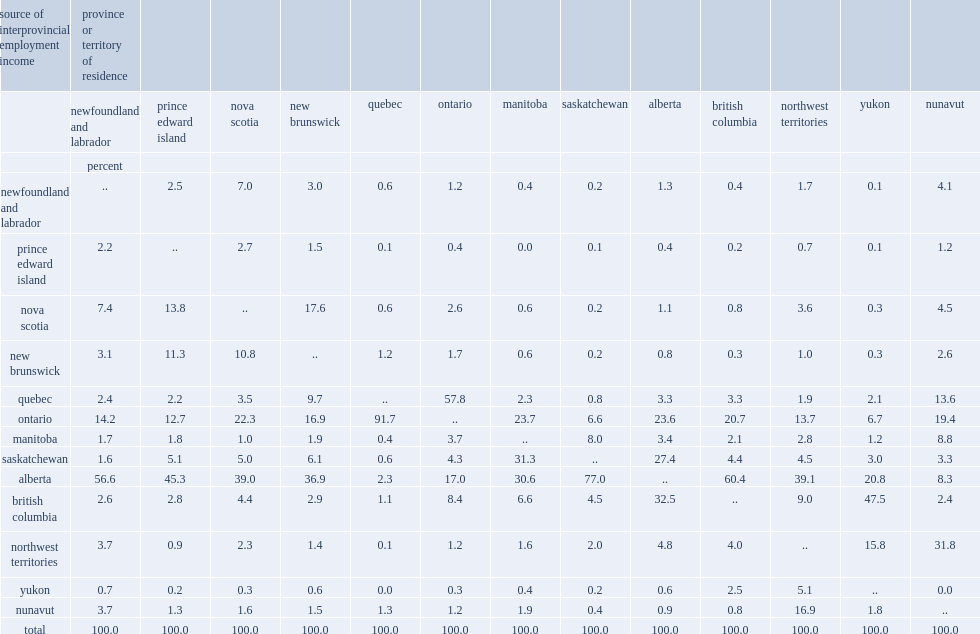For which country does more than half of the interprovincial employment income received in 2011 coming from alberta? Newfoundland and labrador saskatchewan british columbia. What is the range of wages and salaries earned in alberta accounting for in prince edward island, nova scotia, new brunswick, manitoba, and the northwest territories? 30.6 45.3. What is the percentage of quebec's interprovincial employment income from ontario? 91.7. What is the percentage of ontario's interprovincial employment income from quebec? 57.8. What is the percentage of yukon's interprovincial earnings from british columbia? 47.5. Which countries are the three largest sources of interprovincial earnings for nunavut residents? Northwest territories ontario quebec. 